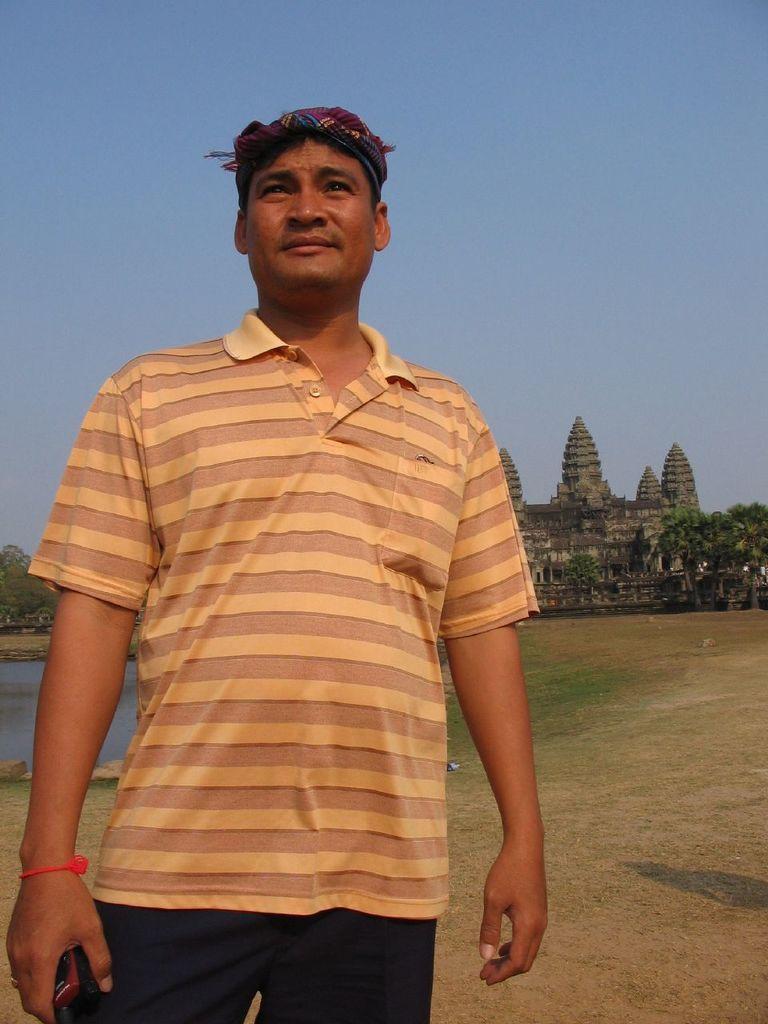Can you describe this image briefly? This is an outside view. On the left side of this image I can see a man wearing t-shirt, trouser, standing and giving pose for the picture. At the back of this man I can see some water. It is looking like a river. In the background there are some trees and I can see a building. At the top I can see the sky. 